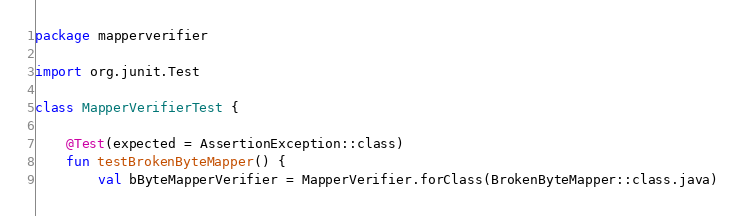Convert code to text. <code><loc_0><loc_0><loc_500><loc_500><_Kotlin_>package mapperverifier

import org.junit.Test

class MapperVerifierTest {

    @Test(expected = AssertionException::class)
    fun testBrokenByteMapper() {
        val bByteMapperVerifier = MapperVerifier.forClass(BrokenByteMapper::class.java)</code> 